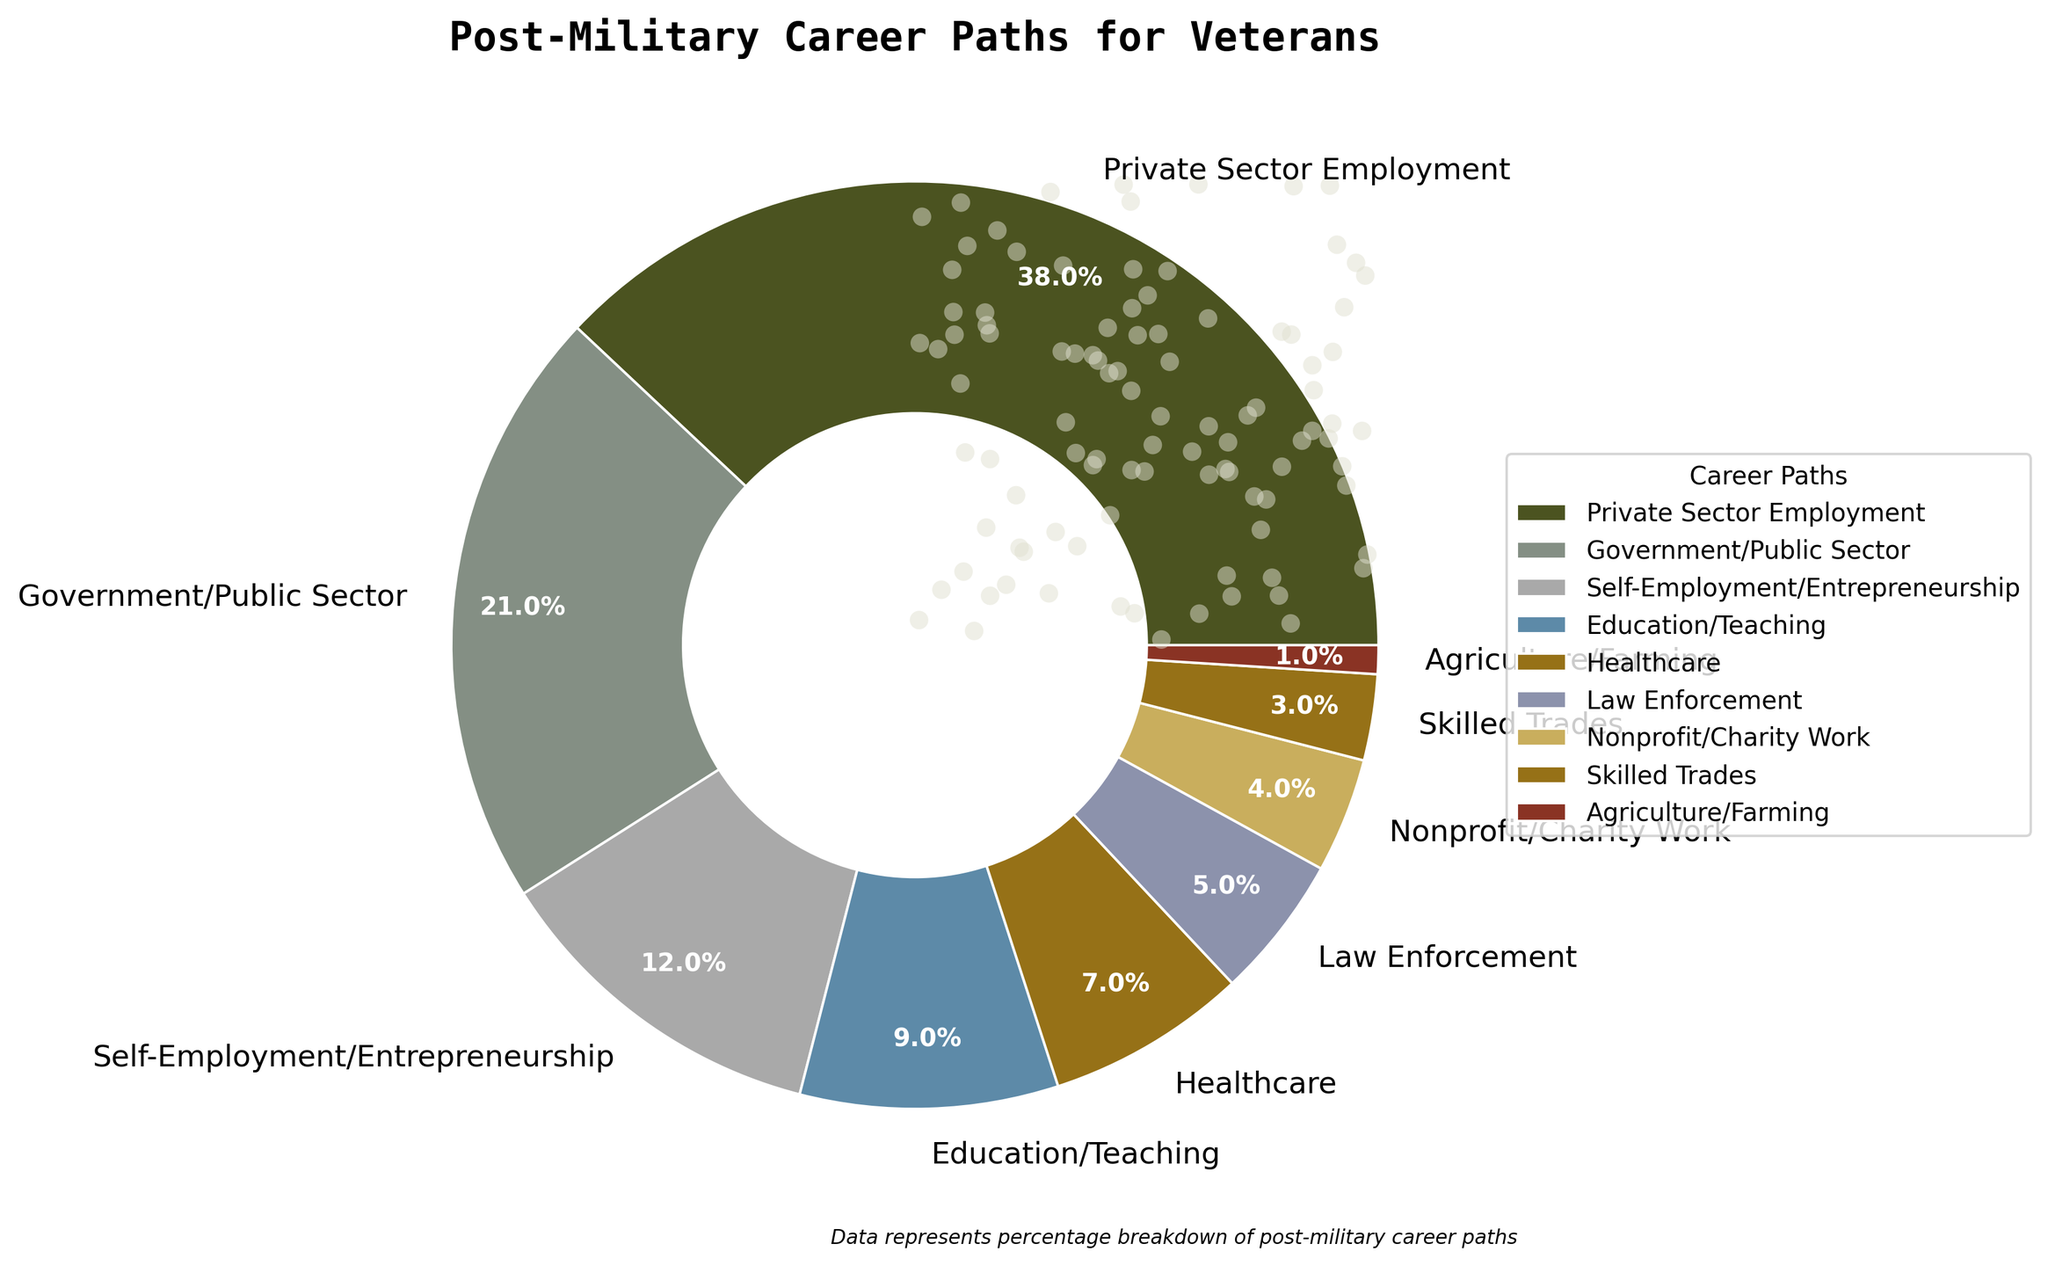Agriculture/Farming only has 1%, which is the smallest segment of the pie chart. Identify the segment on the chart with the smallest percentage, which is represented by the "Agriculture/Farming" slice with 1%.
Answer: Agriculture/Farming Which career path has the highest percentage? Locate the largest segment of the pie chart, which is "Private Sector Employment" with 38%.
Answer: Private Sector Employment How much larger is the percentage for Private Sector Employment compared to Skilled Trades? Calculate the difference between the percentages for "Private Sector Employment" (38%) and "Skilled Trades" (3%): 38% - 3% = 35%.
Answer: 35% Compare the percentages for Government/Public Sector and Education/Teaching. Identify the percentages for "Government/Public Sector" (21%) and "Education/Teaching" (9%). Government/Public Sector is 12% higher than Education/Teaching: 21% - 9% = 12%.
Answer: 12% Sum the percentages for Nonprofit/Charity Work, Skilled Trades, and Agriculture/Farming. Add the percentages for "Nonprofit/Charity Work" (4%), "Skilled Trades" (3%), and "Agriculture/Farming" (1%): 4% + 3% + 1% = 8%.
Answer: 8% Which two career paths together make up more than half of the total percentage? Identify the two largest segments: "Private Sector Employment" (38%) and "Government/Public Sector" (21%). Add them together: 38% + 21% = 59%, which is more than half.
Answer: Private Sector Employment and Government/Public Sector What percentage of veterans are involved in Healthcare? Locate the "Healthcare" segment on the pie chart, which has a percentage of 7%.
Answer: 7% Compare the visual size of the Healthcare slice to the Self-Employment/Entrepreneurship slice. The "Self-Employment/Entrepreneurship" segment is larger at 12%, compared to "Healthcare" which is only 7%. This is reflected visually by the larger segment for Self-Employment/Entrepreneurship.
Answer: Self-Employment/Entrepreneurship is larger Are the percentages for Law Enforcement and Nonprofit/Charity Work equal? Observe the segments for "Law Enforcement" (5%) and "Nonprofit/Charity Work" (4%). They are not equal as Law Enforcement is 1% higher.
Answer: No What percentage categories make up exactly 10% when combined? Combine the percentages for "Skilled Trades" (3%) and "Education/Teaching" (9%): 3% + 9% = 12%, it's more than 10%. Try other combinations: none match exactly 10% but if considering other near combinations like adding (4+1+5 and 2 more points which can be matched nearly) to form step combinations analyzing visually
Answer: No exact match, closest is adding multiple smaller categories 